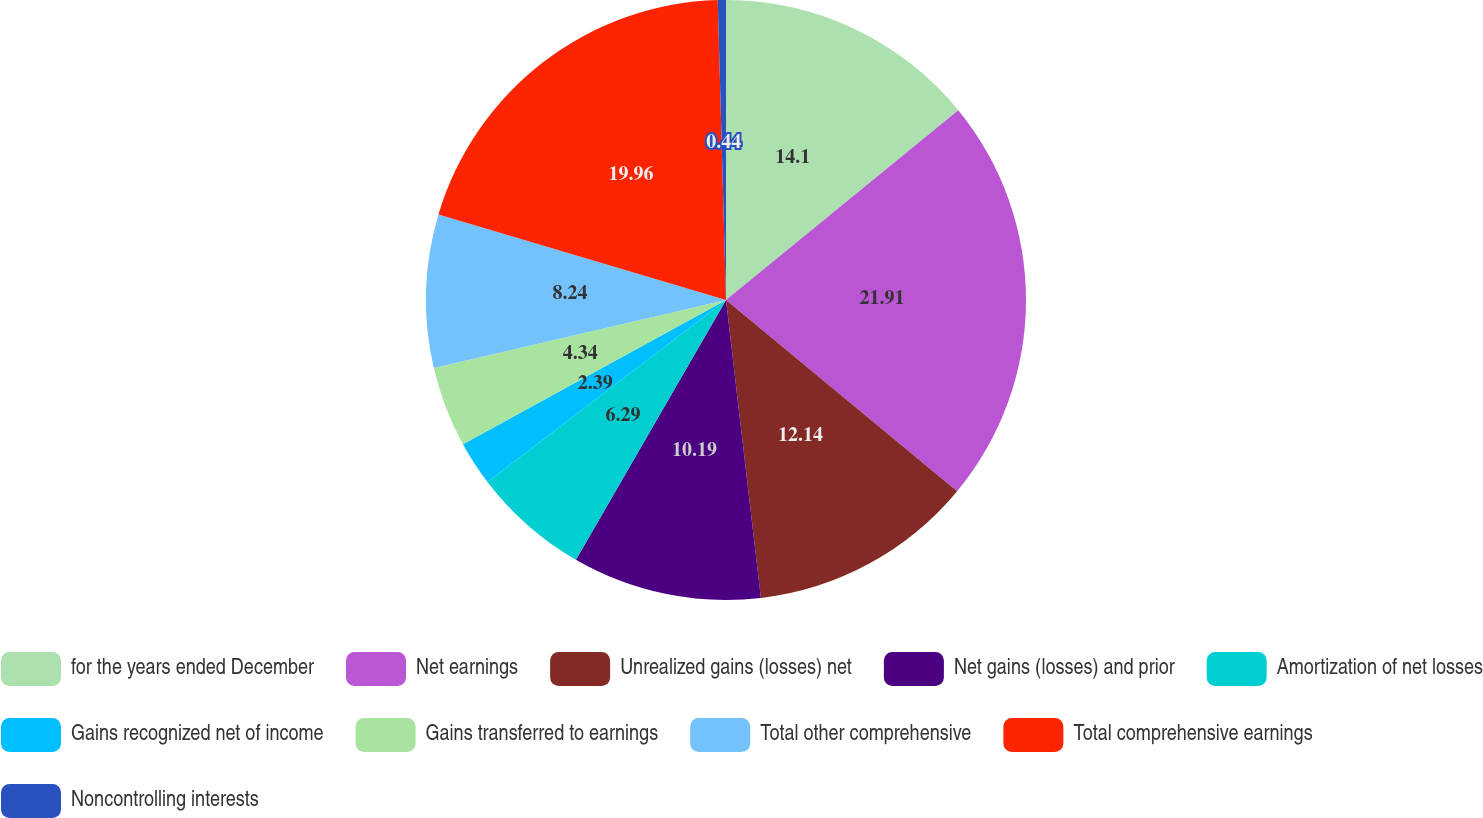<chart> <loc_0><loc_0><loc_500><loc_500><pie_chart><fcel>for the years ended December<fcel>Net earnings<fcel>Unrealized gains (losses) net<fcel>Net gains (losses) and prior<fcel>Amortization of net losses<fcel>Gains recognized net of income<fcel>Gains transferred to earnings<fcel>Total other comprehensive<fcel>Total comprehensive earnings<fcel>Noncontrolling interests<nl><fcel>14.09%<fcel>21.9%<fcel>12.14%<fcel>10.19%<fcel>6.29%<fcel>2.39%<fcel>4.34%<fcel>8.24%<fcel>19.95%<fcel>0.44%<nl></chart> 